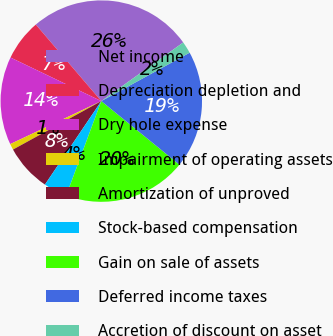<chart> <loc_0><loc_0><loc_500><loc_500><pie_chart><fcel>Net income<fcel>Depreciation depletion and<fcel>Dry hole expense<fcel>Impairment of operating assets<fcel>Amortization of unproved<fcel>Stock-based compensation<fcel>Gain on sale of assets<fcel>Deferred income taxes<fcel>Accretion of discount on asset<nl><fcel>26.38%<fcel>6.61%<fcel>14.14%<fcel>0.97%<fcel>7.56%<fcel>3.79%<fcel>19.79%<fcel>18.85%<fcel>1.91%<nl></chart> 